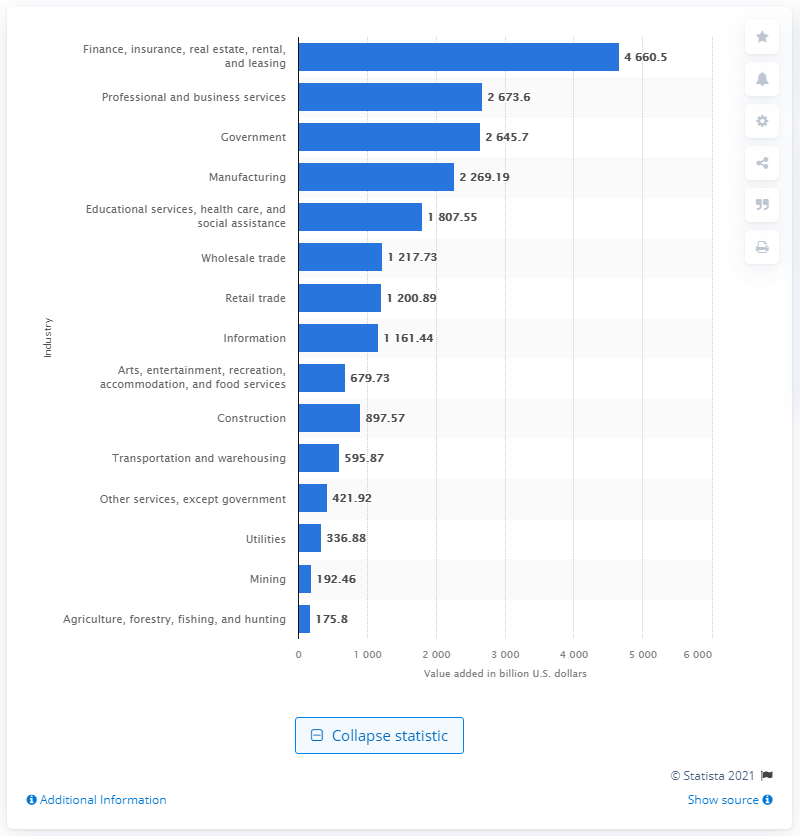Outline some significant characteristics in this image. In 2020, the finance, real estate, insurance, and leasing industry contributed a significant amount to the national GDP, with a total addition of 4660.5. 